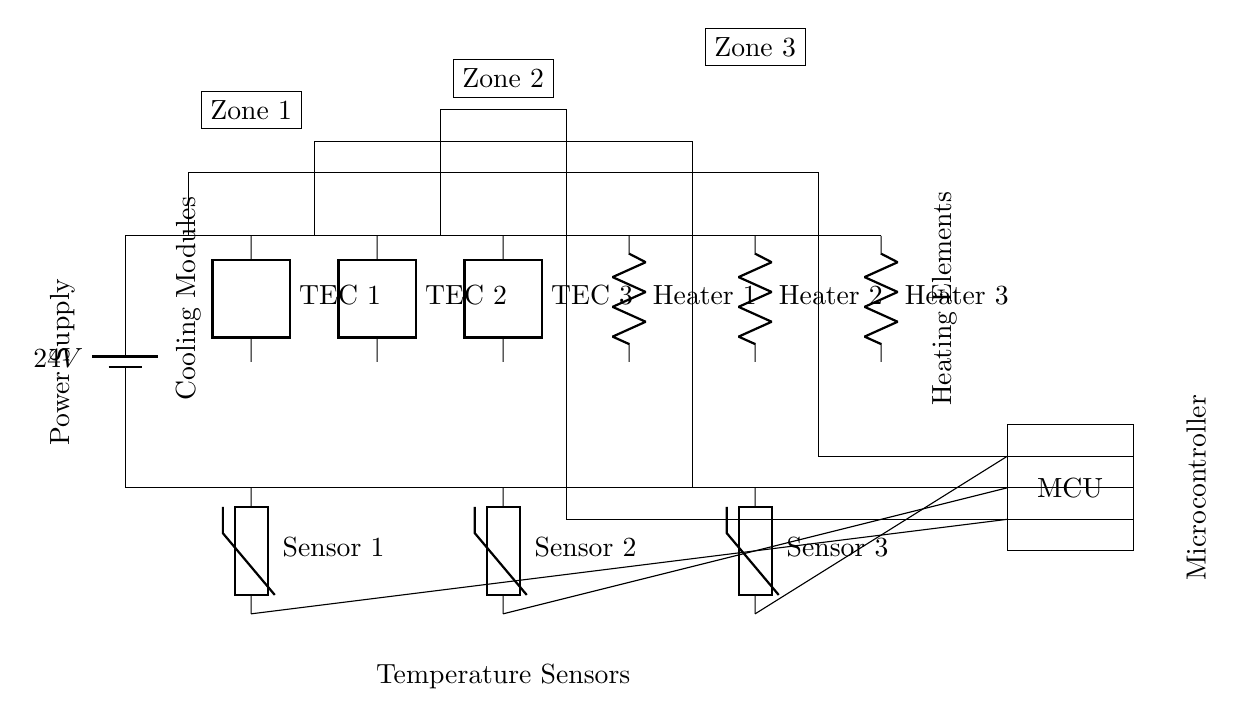What type of power supply is used in this circuit? The circuit uses a battery, specifically indicated as a 24V battery. The voltage label next to the battery clearly states the power source being utilized.
Answer: 24V battery How many thermoelectric cooling modules are present in the circuit? The diagram shows three thermoelectric cooling modules, each labeled as TEC 1, TEC 2, and TEC 3. By counting the modules in the diagram, it's clear that there are three.
Answer: Three What is the role of the Microcontroller in this circuit? The Microcontroller, indicated in the circuit diagram, is responsible for controlling the operation of all connected components based on the readings from the temperature sensors. This involves managing when to activate the heaters or coolers to maintain desired temperatures.
Answer: Control Which components are used for resistive heating? The circuit diagram includes three resistive heating elements labeled as Heater 1, Heater 2, and Heater 3. These are clearly indicated in the diagram as heating components connected to the circuit.
Answer: Three heaters How many temperature sensors are there, and where are they located? The circuit has three temperature sensors, located below the thermoelectric cooling modules. They are labeled as Sensor 1, Sensor 2, and Sensor 3, corresponding to the respective zones. Counting them in the diagram reveals their number and placement.
Answer: Three sensors What zones are designated in the circuit and how are they represented? The circuit includes three distinct zones labeled Zone 1, Zone 2, and Zone 3, represented with rectangles at the top of the diagram. The labeling of each zone indicates the individual climate-controlled areas within the system.
Answer: Three zones How does the circuit combine cooling and heating for climate control? The circuit integrates thermoelectric cooling modules (TEC) with resistive heating elements, allowing precise control of temperature by using one or the other based on sensor readings. The use of both types of elements enables the system to regulate temperature effectively in various conditions.
Answer: Hybrid operation 